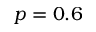Convert formula to latex. <formula><loc_0><loc_0><loc_500><loc_500>p = 0 . 6</formula> 